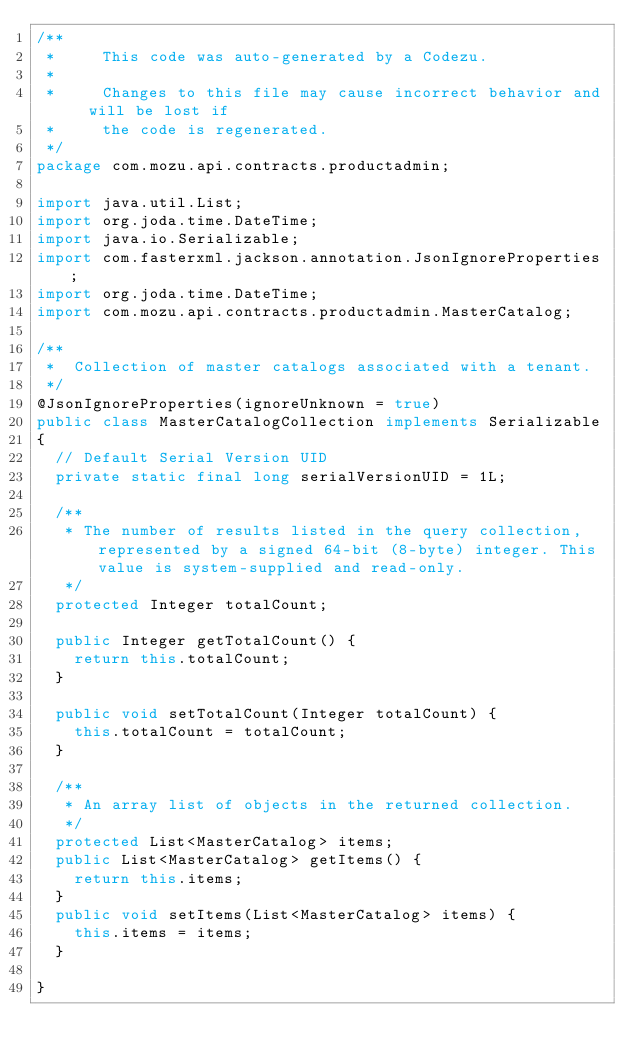<code> <loc_0><loc_0><loc_500><loc_500><_Java_>/**
 *     This code was auto-generated by a Codezu.     
 *
 *     Changes to this file may cause incorrect behavior and will be lost if
 *     the code is regenerated.
 */
package com.mozu.api.contracts.productadmin;

import java.util.List;
import org.joda.time.DateTime;
import java.io.Serializable;
import com.fasterxml.jackson.annotation.JsonIgnoreProperties;
import org.joda.time.DateTime;
import com.mozu.api.contracts.productadmin.MasterCatalog;

/**
 *	Collection of master catalogs associated with a tenant.
 */
@JsonIgnoreProperties(ignoreUnknown = true)
public class MasterCatalogCollection implements Serializable
{
	// Default Serial Version UID
	private static final long serialVersionUID = 1L;

	/**
	 * The number of results listed in the query collection, represented by a signed 64-bit (8-byte) integer. This value is system-supplied and read-only.
	 */
	protected Integer totalCount;

	public Integer getTotalCount() {
		return this.totalCount;
	}

	public void setTotalCount(Integer totalCount) {
		this.totalCount = totalCount;
	}

	/**
	 * An array list of objects in the returned collection.
	 */
	protected List<MasterCatalog> items;
	public List<MasterCatalog> getItems() {
		return this.items;
	}
	public void setItems(List<MasterCatalog> items) {
		this.items = items;
	}

}
</code> 